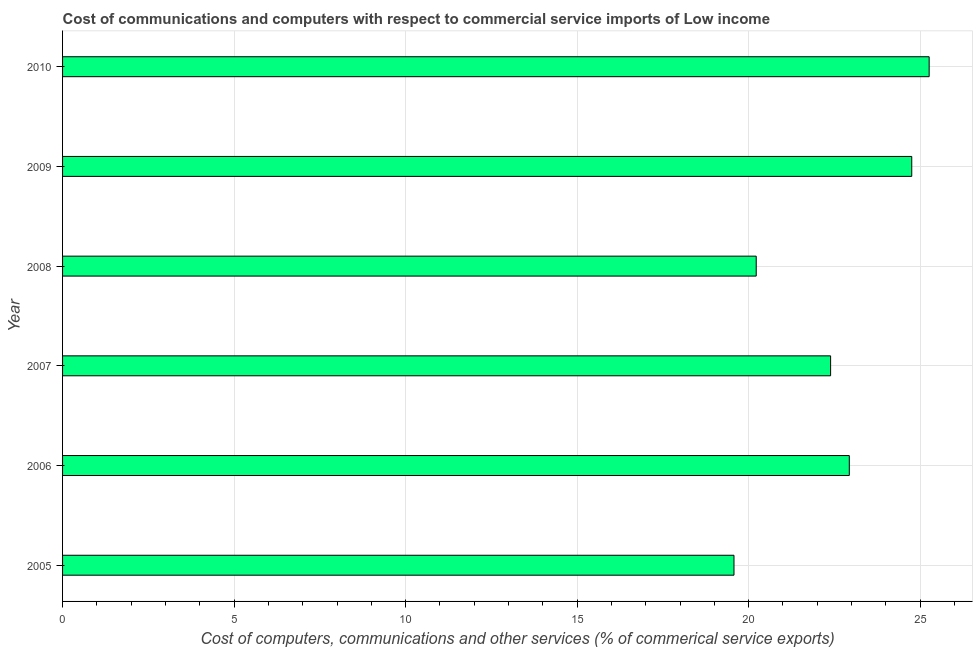Does the graph contain any zero values?
Make the answer very short. No. What is the title of the graph?
Give a very brief answer. Cost of communications and computers with respect to commercial service imports of Low income. What is the label or title of the X-axis?
Your answer should be compact. Cost of computers, communications and other services (% of commerical service exports). What is the  computer and other services in 2005?
Ensure brevity in your answer.  19.57. Across all years, what is the maximum cost of communications?
Offer a very short reply. 25.26. Across all years, what is the minimum cost of communications?
Your answer should be very brief. 19.57. What is the sum of the cost of communications?
Offer a very short reply. 135.13. What is the difference between the  computer and other services in 2005 and 2008?
Offer a terse response. -0.65. What is the average  computer and other services per year?
Provide a succinct answer. 22.52. What is the median cost of communications?
Offer a terse response. 22.66. In how many years, is the  computer and other services greater than 2 %?
Offer a very short reply. 6. Do a majority of the years between 2009 and 2010 (inclusive) have cost of communications greater than 14 %?
Provide a succinct answer. Yes. What is the ratio of the  computer and other services in 2007 to that in 2008?
Give a very brief answer. 1.11. Is the  computer and other services in 2008 less than that in 2010?
Make the answer very short. Yes. Is the difference between the  computer and other services in 2005 and 2009 greater than the difference between any two years?
Your answer should be compact. No. What is the difference between the highest and the second highest  computer and other services?
Ensure brevity in your answer.  0.51. What is the difference between the highest and the lowest cost of communications?
Give a very brief answer. 5.69. What is the difference between two consecutive major ticks on the X-axis?
Offer a terse response. 5. What is the Cost of computers, communications and other services (% of commerical service exports) of 2005?
Keep it short and to the point. 19.57. What is the Cost of computers, communications and other services (% of commerical service exports) of 2006?
Provide a succinct answer. 22.93. What is the Cost of computers, communications and other services (% of commerical service exports) of 2007?
Offer a terse response. 22.39. What is the Cost of computers, communications and other services (% of commerical service exports) of 2008?
Give a very brief answer. 20.22. What is the Cost of computers, communications and other services (% of commerical service exports) of 2009?
Offer a very short reply. 24.76. What is the Cost of computers, communications and other services (% of commerical service exports) of 2010?
Ensure brevity in your answer.  25.26. What is the difference between the Cost of computers, communications and other services (% of commerical service exports) in 2005 and 2006?
Provide a short and direct response. -3.36. What is the difference between the Cost of computers, communications and other services (% of commerical service exports) in 2005 and 2007?
Provide a short and direct response. -2.82. What is the difference between the Cost of computers, communications and other services (% of commerical service exports) in 2005 and 2008?
Ensure brevity in your answer.  -0.65. What is the difference between the Cost of computers, communications and other services (% of commerical service exports) in 2005 and 2009?
Your response must be concise. -5.18. What is the difference between the Cost of computers, communications and other services (% of commerical service exports) in 2005 and 2010?
Keep it short and to the point. -5.69. What is the difference between the Cost of computers, communications and other services (% of commerical service exports) in 2006 and 2007?
Offer a very short reply. 0.54. What is the difference between the Cost of computers, communications and other services (% of commerical service exports) in 2006 and 2008?
Your answer should be very brief. 2.71. What is the difference between the Cost of computers, communications and other services (% of commerical service exports) in 2006 and 2009?
Ensure brevity in your answer.  -1.82. What is the difference between the Cost of computers, communications and other services (% of commerical service exports) in 2006 and 2010?
Your response must be concise. -2.33. What is the difference between the Cost of computers, communications and other services (% of commerical service exports) in 2007 and 2008?
Your response must be concise. 2.17. What is the difference between the Cost of computers, communications and other services (% of commerical service exports) in 2007 and 2009?
Your answer should be compact. -2.37. What is the difference between the Cost of computers, communications and other services (% of commerical service exports) in 2007 and 2010?
Your response must be concise. -2.87. What is the difference between the Cost of computers, communications and other services (% of commerical service exports) in 2008 and 2009?
Offer a very short reply. -4.53. What is the difference between the Cost of computers, communications and other services (% of commerical service exports) in 2008 and 2010?
Offer a very short reply. -5.04. What is the difference between the Cost of computers, communications and other services (% of commerical service exports) in 2009 and 2010?
Your answer should be compact. -0.51. What is the ratio of the Cost of computers, communications and other services (% of commerical service exports) in 2005 to that in 2006?
Your answer should be compact. 0.85. What is the ratio of the Cost of computers, communications and other services (% of commerical service exports) in 2005 to that in 2007?
Your answer should be very brief. 0.87. What is the ratio of the Cost of computers, communications and other services (% of commerical service exports) in 2005 to that in 2009?
Offer a terse response. 0.79. What is the ratio of the Cost of computers, communications and other services (% of commerical service exports) in 2005 to that in 2010?
Offer a very short reply. 0.78. What is the ratio of the Cost of computers, communications and other services (% of commerical service exports) in 2006 to that in 2008?
Give a very brief answer. 1.13. What is the ratio of the Cost of computers, communications and other services (% of commerical service exports) in 2006 to that in 2009?
Make the answer very short. 0.93. What is the ratio of the Cost of computers, communications and other services (% of commerical service exports) in 2006 to that in 2010?
Keep it short and to the point. 0.91. What is the ratio of the Cost of computers, communications and other services (% of commerical service exports) in 2007 to that in 2008?
Keep it short and to the point. 1.11. What is the ratio of the Cost of computers, communications and other services (% of commerical service exports) in 2007 to that in 2009?
Your answer should be compact. 0.9. What is the ratio of the Cost of computers, communications and other services (% of commerical service exports) in 2007 to that in 2010?
Give a very brief answer. 0.89. What is the ratio of the Cost of computers, communications and other services (% of commerical service exports) in 2008 to that in 2009?
Keep it short and to the point. 0.82. What is the ratio of the Cost of computers, communications and other services (% of commerical service exports) in 2009 to that in 2010?
Make the answer very short. 0.98. 